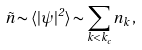<formula> <loc_0><loc_0><loc_500><loc_500>\tilde { n } \sim \langle | \psi | ^ { 2 } \rangle \sim \sum _ { k < k _ { c } } n _ { k } \, ,</formula> 